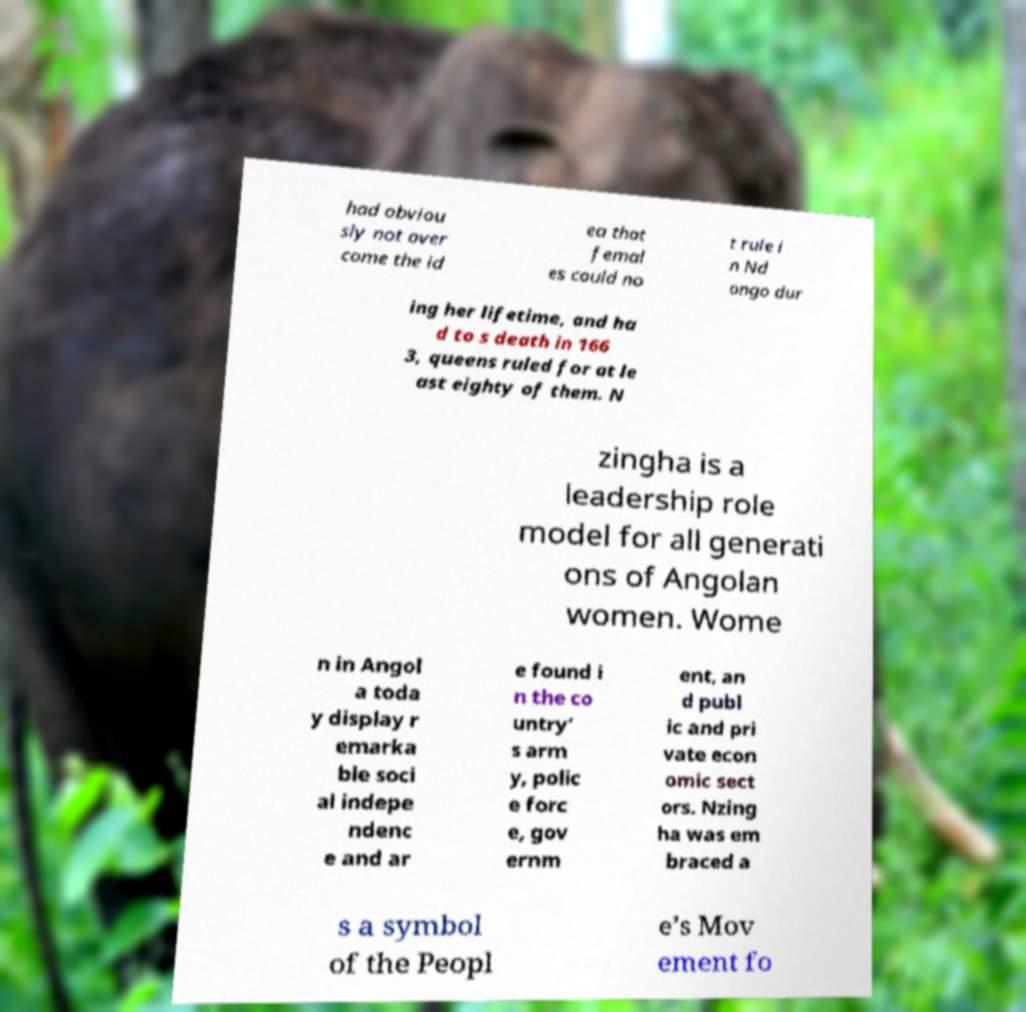Can you read and provide the text displayed in the image?This photo seems to have some interesting text. Can you extract and type it out for me? had obviou sly not over come the id ea that femal es could no t rule i n Nd ongo dur ing her lifetime, and ha d to s death in 166 3, queens ruled for at le ast eighty of them. N zingha is a leadership role model for all generati ons of Angolan women. Wome n in Angol a toda y display r emarka ble soci al indepe ndenc e and ar e found i n the co untry’ s arm y, polic e forc e, gov ernm ent, an d publ ic and pri vate econ omic sect ors. Nzing ha was em braced a s a symbol of the Peopl e’s Mov ement fo 